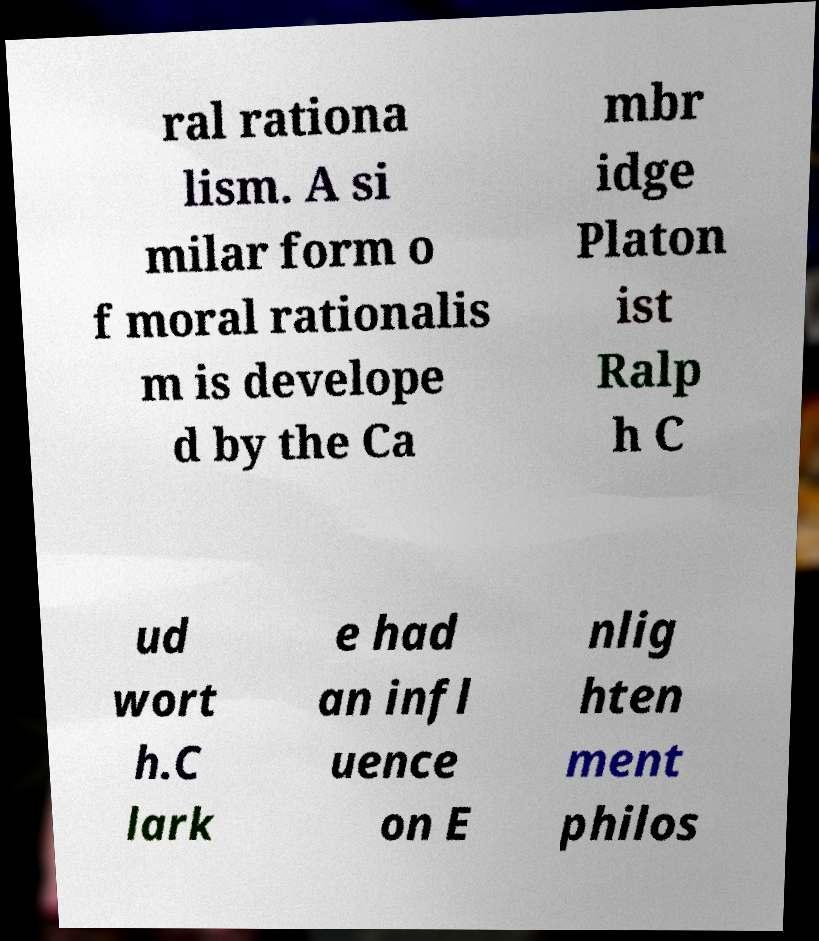Could you assist in decoding the text presented in this image and type it out clearly? ral rationa lism. A si milar form o f moral rationalis m is develope d by the Ca mbr idge Platon ist Ralp h C ud wort h.C lark e had an infl uence on E nlig hten ment philos 